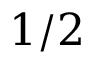Convert formula to latex. <formula><loc_0><loc_0><loc_500><loc_500>1 / 2</formula> 